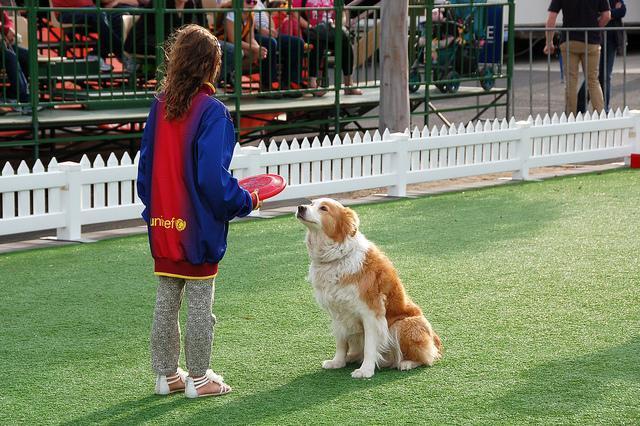How many dogs are there?
Give a very brief answer. 1. How many people are there?
Give a very brief answer. 5. How many giraffes are not reaching towards the woman?
Give a very brief answer. 0. 